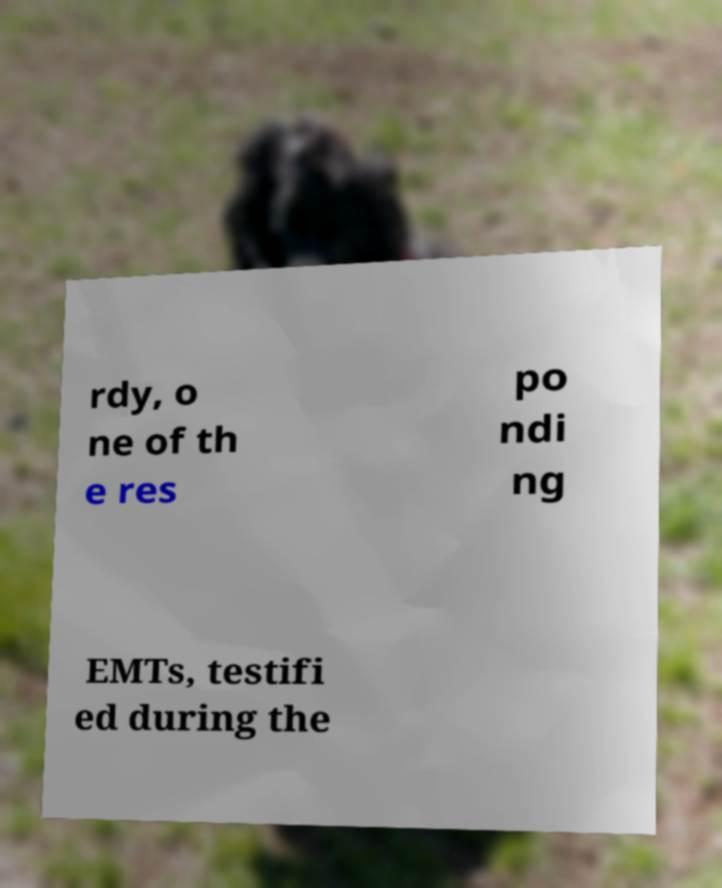I need the written content from this picture converted into text. Can you do that? rdy, o ne of th e res po ndi ng EMTs, testifi ed during the 